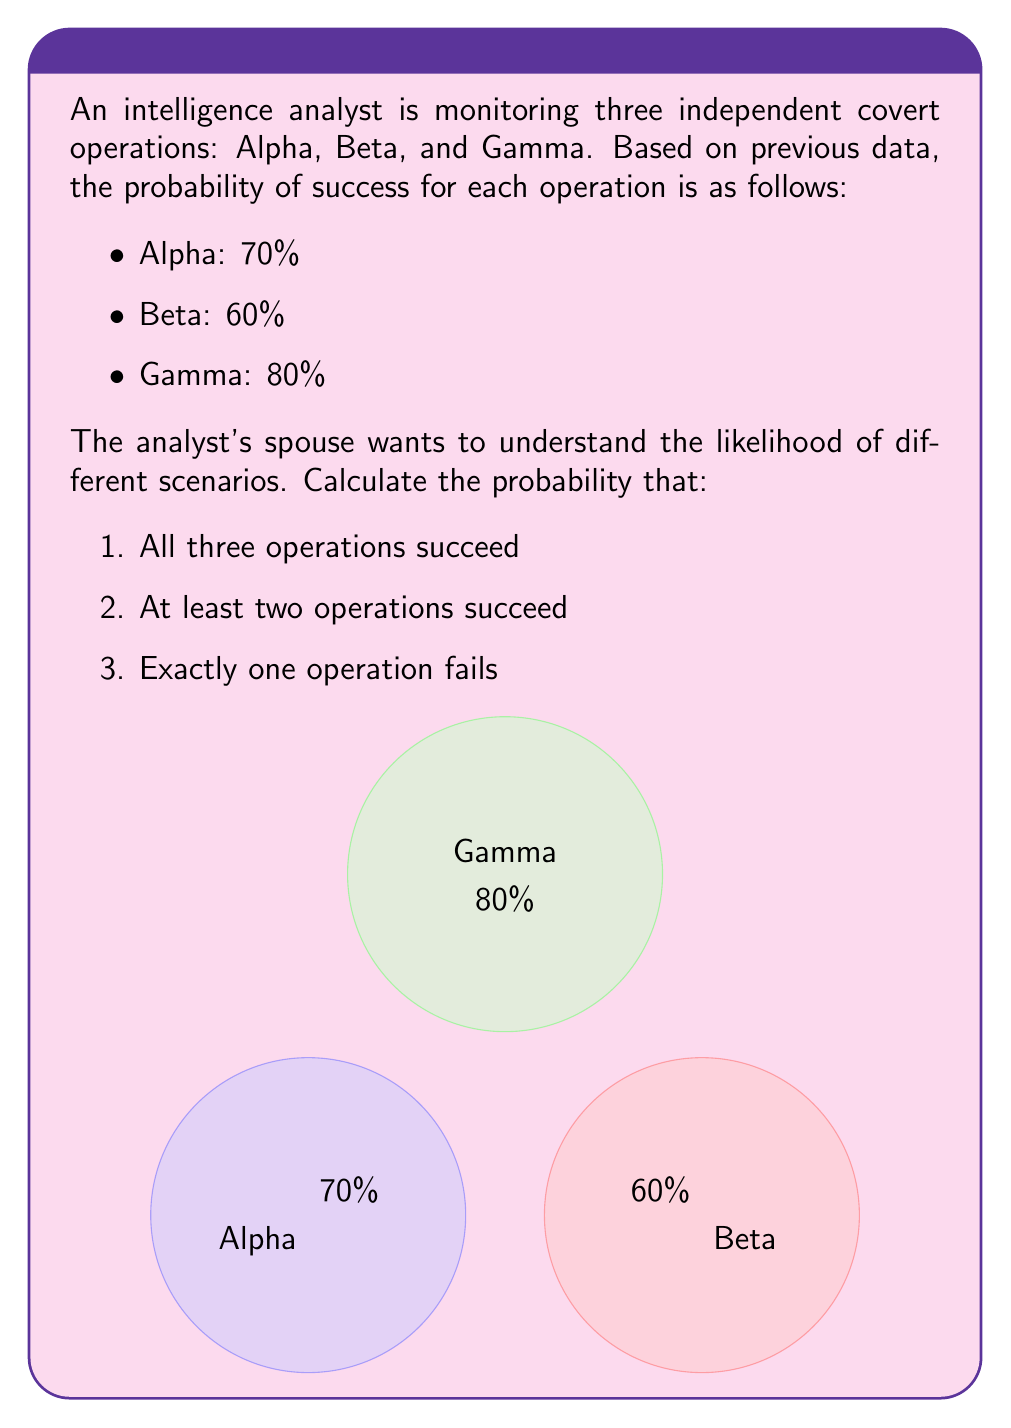Teach me how to tackle this problem. Let's approach this step-by-step:

1. Probability of all three operations succeeding:
   We multiply the individual probabilities since the events are independent.
   $$P(\text{All succeed}) = 0.70 \times 0.60 \times 0.80 = 0.336 = 33.6\%$$

2. Probability of at least two operations succeeding:
   It's easier to calculate the probability of two or more succeeding by subtracting the probability of zero or one succeeding from 1.

   First, let's calculate the probability of each operation failing:
   Alpha: $1 - 0.70 = 0.30$
   Beta: $1 - 0.60 = 0.40$
   Gamma: $1 - 0.80 = 0.20$

   Now, we can calculate:
   $$\begin{align*}
   P(\text{At least two succeed}) &= 1 - P(\text{Zero or one succeed}) \\
   &= 1 - [P(\text{All fail}) + P(\text{Only Alpha succeeds}) + P(\text{Only Beta succeeds}) + P(\text{Only Gamma succeeds})] \\
   &= 1 - [(0.30 \times 0.40 \times 0.20) + (0.70 \times 0.40 \times 0.20) + (0.30 \times 0.60 \times 0.20) + (0.30 \times 0.40 \times 0.80)] \\
   &= 1 - [0.024 + 0.056 + 0.036 + 0.096] \\
   &= 1 - 0.212 = 0.788 = 78.8\%
   \end{align*}$$

3. Probability of exactly one operation failing:
   This is equivalent to the probability of exactly two operations succeeding.
   $$\begin{align*}
   P(\text{Exactly one fails}) &= P(\text{Alpha and Beta succeed}) + P(\text{Alpha and Gamma succeed}) + P(\text{Beta and Gamma succeed}) \\
   &= (0.70 \times 0.60 \times 0.20) + (0.70 \times 0.40 \times 0.80) + (0.30 \times 0.60 \times 0.80) \\
   &= 0.084 + 0.224 + 0.144 \\
   &= 0.452 = 45.2\%
   \end{align*}$$
Answer: 1. 33.6%
2. 78.8%
3. 45.2% 